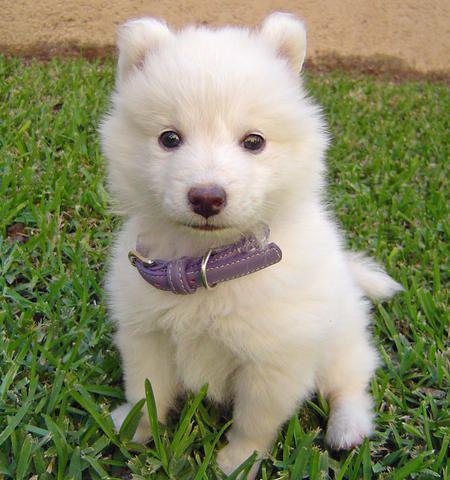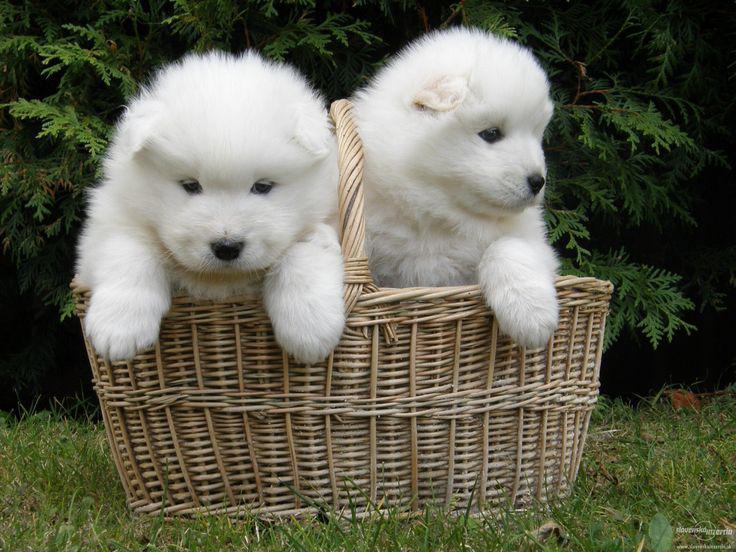The first image is the image on the left, the second image is the image on the right. Examine the images to the left and right. Is the description "One image contains exactly two dogs side-by-side, and the other features one non-standing dog." accurate? Answer yes or no. Yes. The first image is the image on the left, the second image is the image on the right. For the images shown, is this caption "The right image contains exactly two white dogs." true? Answer yes or no. Yes. 